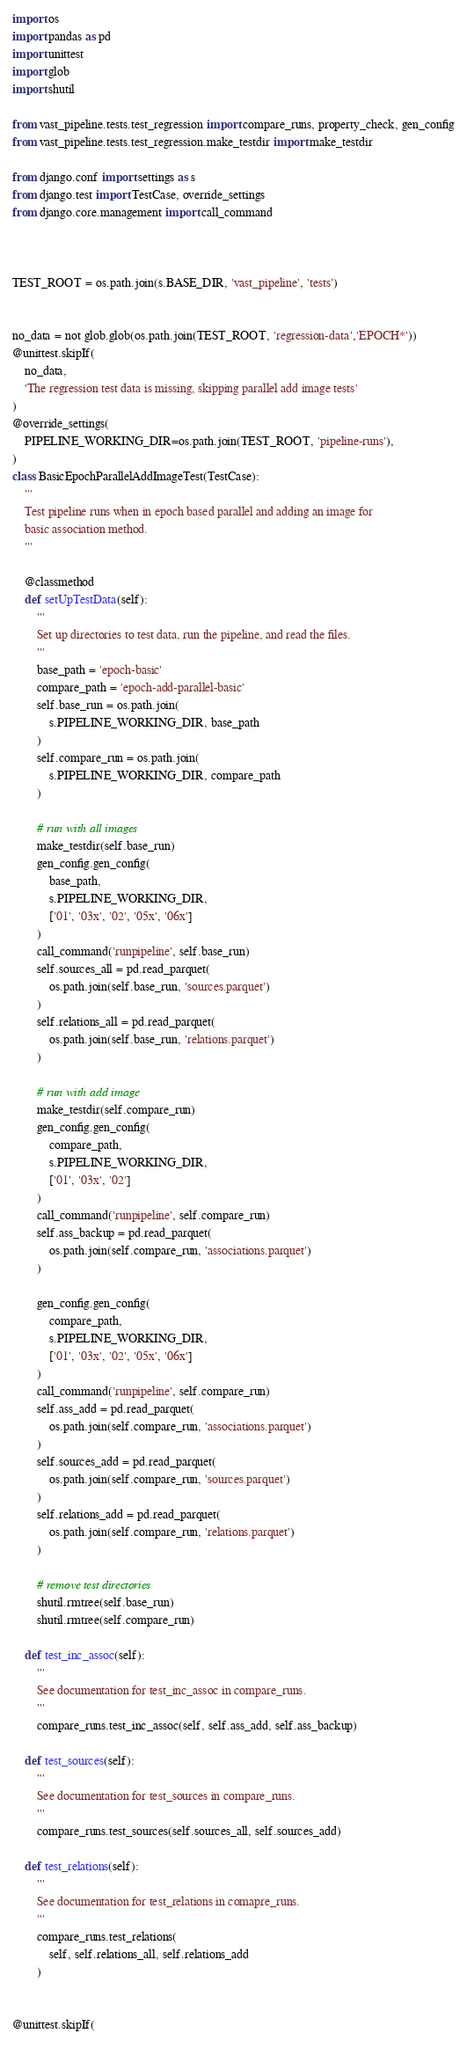<code> <loc_0><loc_0><loc_500><loc_500><_Python_>import os
import pandas as pd
import unittest
import glob
import shutil

from vast_pipeline.tests.test_regression import compare_runs, property_check, gen_config
from vast_pipeline.tests.test_regression.make_testdir import make_testdir

from django.conf import settings as s
from django.test import TestCase, override_settings
from django.core.management import call_command



TEST_ROOT = os.path.join(s.BASE_DIR, 'vast_pipeline', 'tests')


no_data = not glob.glob(os.path.join(TEST_ROOT, 'regression-data','EPOCH*'))
@unittest.skipIf(
    no_data,
    'The regression test data is missing, skipping parallel add image tests'
)
@override_settings(
    PIPELINE_WORKING_DIR=os.path.join(TEST_ROOT, 'pipeline-runs'),
)
class BasicEpochParallelAddImageTest(TestCase):
    '''
    Test pipeline runs when in epoch based parallel and adding an image for
    basic association method.
    '''

    @classmethod
    def setUpTestData(self):
        '''
        Set up directories to test data, run the pipeline, and read the files.
        '''
        base_path = 'epoch-basic'
        compare_path = 'epoch-add-parallel-basic'
        self.base_run = os.path.join(
            s.PIPELINE_WORKING_DIR, base_path
        )
        self.compare_run = os.path.join(
            s.PIPELINE_WORKING_DIR, compare_path
        )

        # run with all images
        make_testdir(self.base_run)
        gen_config.gen_config(
            base_path,
            s.PIPELINE_WORKING_DIR,
            ['01', '03x', '02', '05x', '06x']
        )
        call_command('runpipeline', self.base_run)
        self.sources_all = pd.read_parquet(
            os.path.join(self.base_run, 'sources.parquet')
        )
        self.relations_all = pd.read_parquet(
            os.path.join(self.base_run, 'relations.parquet')
        )

        # run with add image
        make_testdir(self.compare_run)
        gen_config.gen_config(
            compare_path,
            s.PIPELINE_WORKING_DIR,
            ['01', '03x', '02']
        )
        call_command('runpipeline', self.compare_run)
        self.ass_backup = pd.read_parquet(
            os.path.join(self.compare_run, 'associations.parquet')
        )

        gen_config.gen_config(
            compare_path,
            s.PIPELINE_WORKING_DIR,
            ['01', '03x', '02', '05x', '06x']
        )
        call_command('runpipeline', self.compare_run)
        self.ass_add = pd.read_parquet(
            os.path.join(self.compare_run, 'associations.parquet')
        )
        self.sources_add = pd.read_parquet(
            os.path.join(self.compare_run, 'sources.parquet')
        )
        self.relations_add = pd.read_parquet(
            os.path.join(self.compare_run, 'relations.parquet')
        )

        # remove test directories
        shutil.rmtree(self.base_run)
        shutil.rmtree(self.compare_run)

    def test_inc_assoc(self):
        '''
        See documentation for test_inc_assoc in compare_runs.
        '''
        compare_runs.test_inc_assoc(self, self.ass_add, self.ass_backup)

    def test_sources(self):
        '''
        See documentation for test_sources in compare_runs.
        '''
        compare_runs.test_sources(self.sources_all, self.sources_add)

    def test_relations(self):
        '''
        See documentation for test_relations in comapre_runs.
        '''
        compare_runs.test_relations(
            self, self.relations_all, self.relations_add
        )


@unittest.skipIf(</code> 